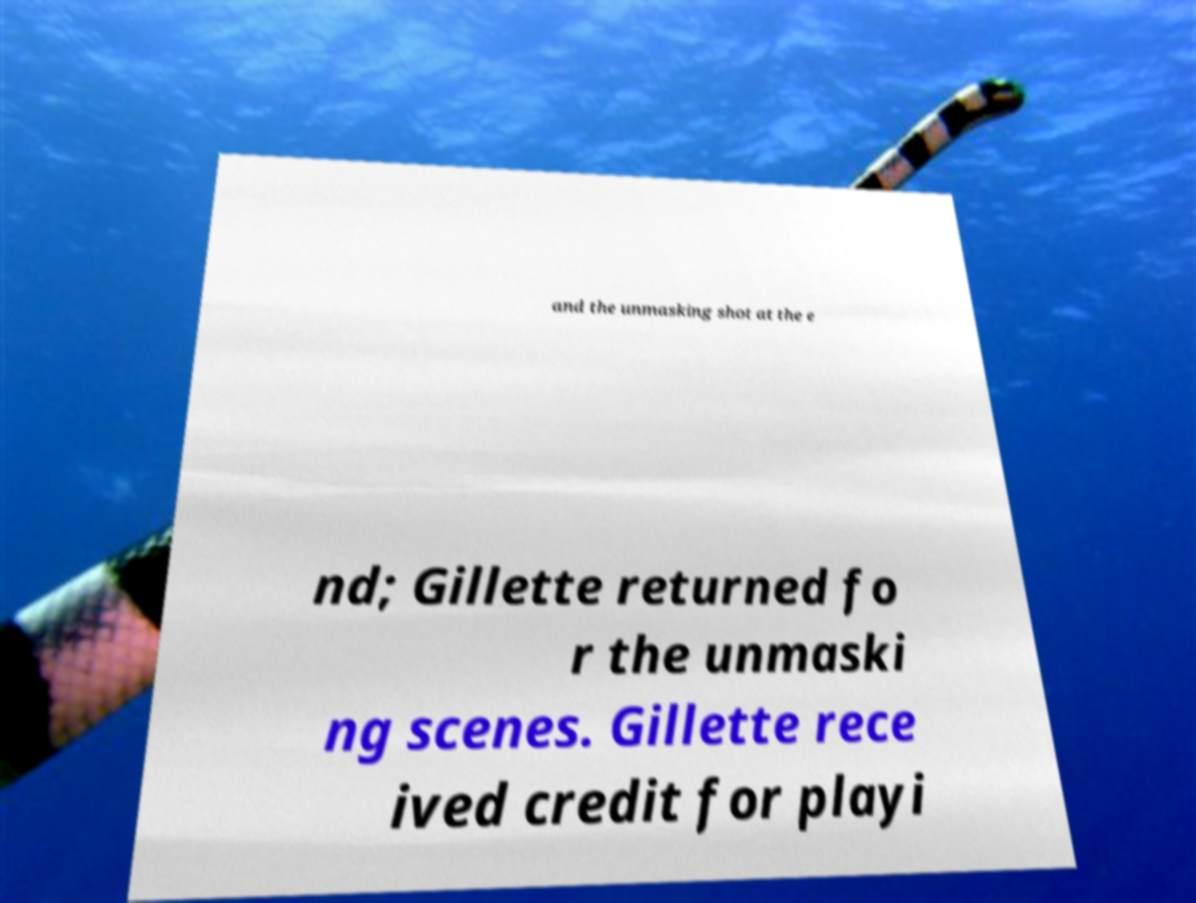Could you assist in decoding the text presented in this image and type it out clearly? and the unmasking shot at the e nd; Gillette returned fo r the unmaski ng scenes. Gillette rece ived credit for playi 